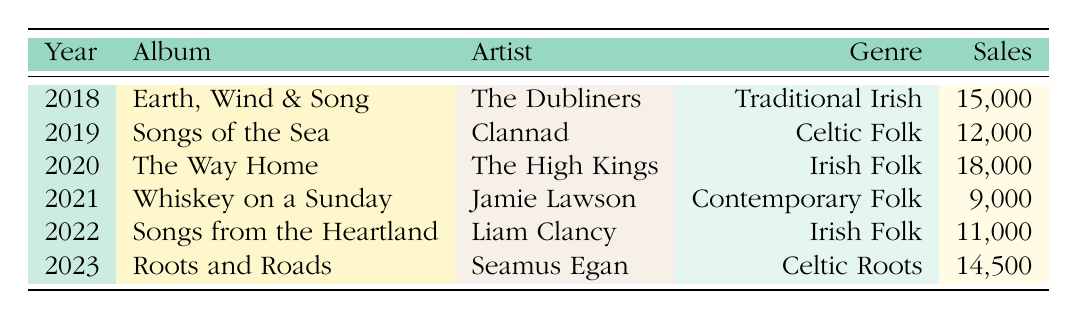What is the highest-selling album in this table? Looking at the sales column, "The Way Home" by The High Kings with 18,000 sales is the highest value.
Answer: The Way Home What genre did "Roots and Roads" belong to? The genre for "Roots and Roads" is listed as Celtic Roots in the table.
Answer: Celtic Roots How many albums sold more than 12,000 copies? The albums with sales greater than 12,000 are "Earth, Wind & Song" (15,000), "The Way Home" (18,000), and "Roots and Roads" (14,500). This totals 3 albums.
Answer: 3 What is the total sales of albums in the Irish Folk genre? The sales for Irish Folk albums are "The Way Home" (18,000) and "Songs from the Heartland" (11,000). Adding these gives: 18,000 + 11,000 = 29,000.
Answer: 29,000 Did any album sell exactly 9,000 copies? "Whiskey on a Sunday" sold exactly 9,000 copies, as noted in the sales column of the table.
Answer: Yes What was the average sales figure for all albums listed in the table? The total sales amount to 15,000 + 12,000 + 18,000 + 9,000 + 11,000 + 14,500 = 79,500. There are 6 albums, so the average sales is 79,500 / 6 = 13,250.
Answer: 13,250 Which artist had the lowest album sales, and how many copies did it sell? The lowest sales figure is for "Whiskey on a Sunday" by Jamie Lawson with 9,000 copies sold.
Answer: Jamie Lawson, 9,000 What genre has the highest total sales? To find the genre with the highest sales, we tally: Traditional Irish (15,000) + Celtic Folk (12,000) + Irish Folk (29,000 from 18,000 and 11,000) + Contemporary Folk (9,000) + Celtic Roots (14,500). Irish Folk has the highest total at 29,000.
Answer: Irish Folk 